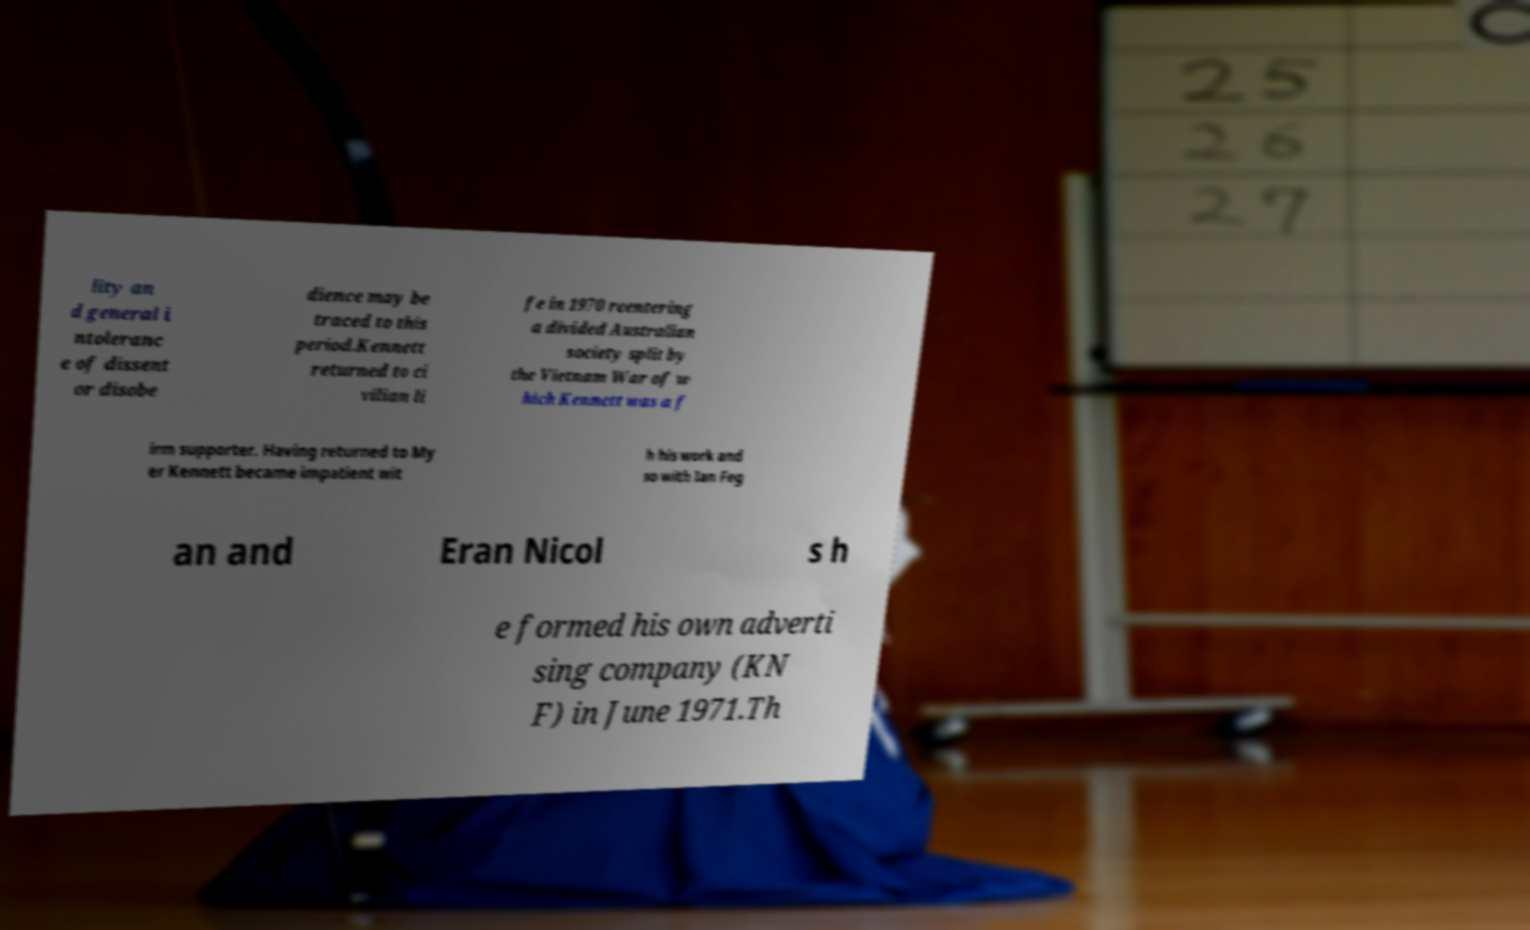Please read and relay the text visible in this image. What does it say? lity an d general i ntoleranc e of dissent or disobe dience may be traced to this period.Kennett returned to ci vilian li fe in 1970 reentering a divided Australian society split by the Vietnam War of w hich Kennett was a f irm supporter. Having returned to My er Kennett became impatient wit h his work and so with Ian Feg an and Eran Nicol s h e formed his own adverti sing company (KN F) in June 1971.Th 